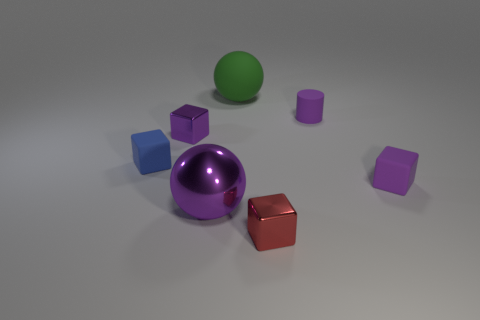What is the material of the cube that is to the right of the cylinder?
Make the answer very short. Rubber. Are there the same number of purple blocks that are behind the small blue cube and large purple metal objects that are in front of the small red thing?
Make the answer very short. No. Is the size of the red cube in front of the big matte ball the same as the thing that is to the right of the purple cylinder?
Keep it short and to the point. Yes. There is a cylinder that is the same color as the metal sphere; what is it made of?
Your answer should be very brief. Rubber. Is the number of cylinders behind the big matte object greater than the number of purple matte cubes?
Make the answer very short. No. Do the green rubber object and the large purple metallic thing have the same shape?
Offer a terse response. Yes. What number of big balls are made of the same material as the big purple object?
Provide a succinct answer. 0. There is another object that is the same shape as the green rubber thing; what size is it?
Ensure brevity in your answer.  Large. Is the size of the red metallic block the same as the purple metallic ball?
Provide a short and direct response. No. What shape is the tiny shiny object behind the small purple object in front of the purple cube behind the small purple matte cube?
Give a very brief answer. Cube. 